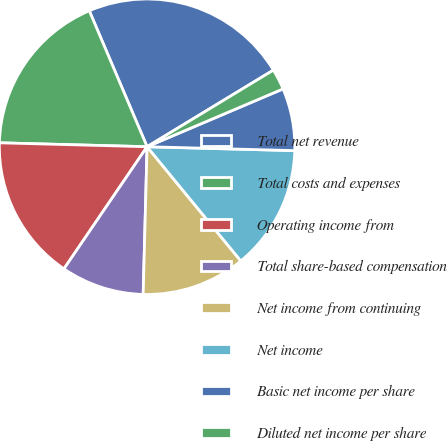Convert chart to OTSL. <chart><loc_0><loc_0><loc_500><loc_500><pie_chart><fcel>Total net revenue<fcel>Total costs and expenses<fcel>Operating income from<fcel>Total share-based compensation<fcel>Net income from continuing<fcel>Net income<fcel>Basic net income per share<fcel>Diluted net income per share<nl><fcel>22.72%<fcel>18.18%<fcel>15.91%<fcel>9.09%<fcel>11.36%<fcel>13.64%<fcel>6.82%<fcel>2.28%<nl></chart> 